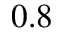<formula> <loc_0><loc_0><loc_500><loc_500>0 . 8</formula> 